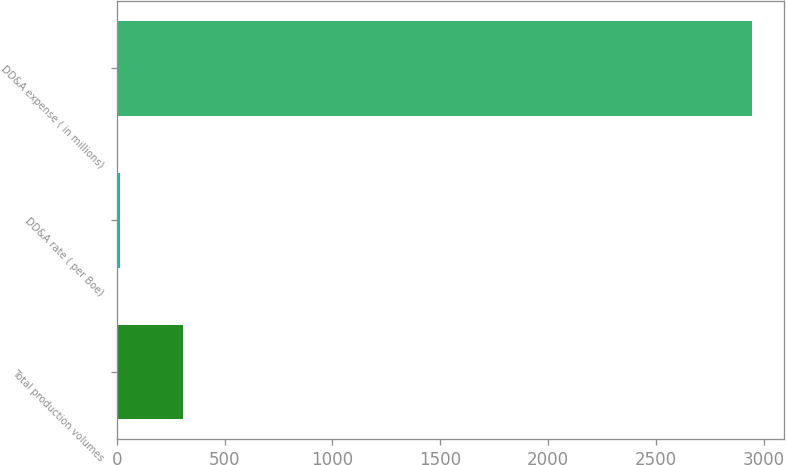Convert chart. <chart><loc_0><loc_0><loc_500><loc_500><bar_chart><fcel>Total production volumes<fcel>DD&A rate ( per Boe)<fcel>DD&A expense ( in millions)<nl><fcel>306.68<fcel>13.2<fcel>2948<nl></chart> 